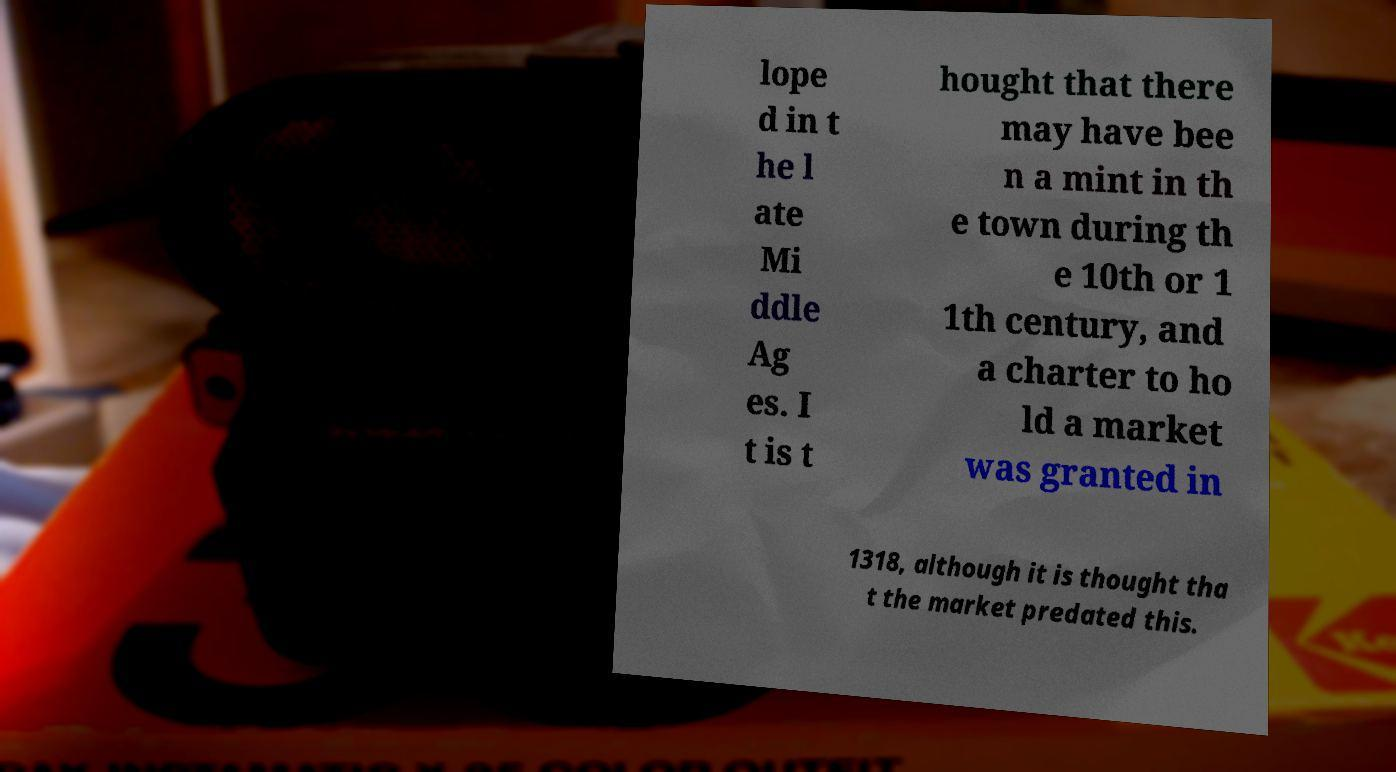Could you assist in decoding the text presented in this image and type it out clearly? lope d in t he l ate Mi ddle Ag es. I t is t hought that there may have bee n a mint in th e town during th e 10th or 1 1th century, and a charter to ho ld a market was granted in 1318, although it is thought tha t the market predated this. 